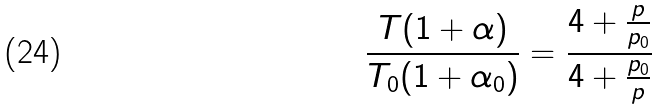Convert formula to latex. <formula><loc_0><loc_0><loc_500><loc_500>\frac { T ( 1 + \alpha ) } { T _ { 0 } ( 1 + \alpha _ { 0 } ) } = \frac { 4 + \frac { p } { p _ { 0 } } } { 4 + \frac { p _ { 0 } } { p } }</formula> 